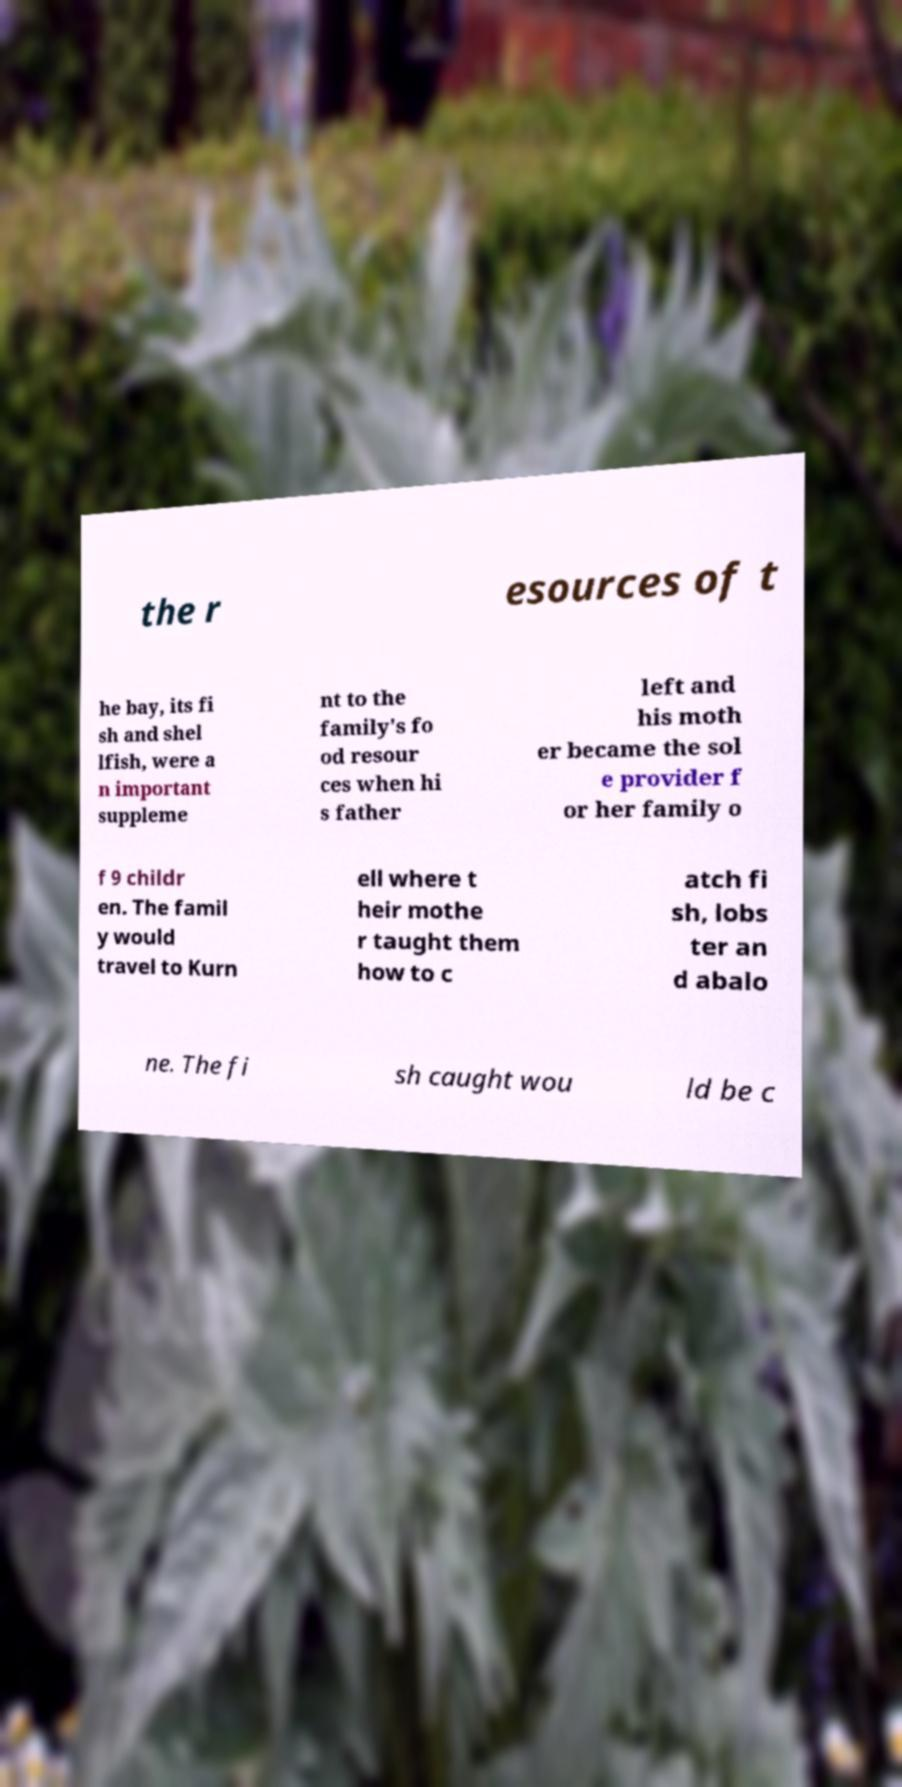Please read and relay the text visible in this image. What does it say? the r esources of t he bay, its fi sh and shel lfish, were a n important suppleme nt to the family's fo od resour ces when hi s father left and his moth er became the sol e provider f or her family o f 9 childr en. The famil y would travel to Kurn ell where t heir mothe r taught them how to c atch fi sh, lobs ter an d abalo ne. The fi sh caught wou ld be c 